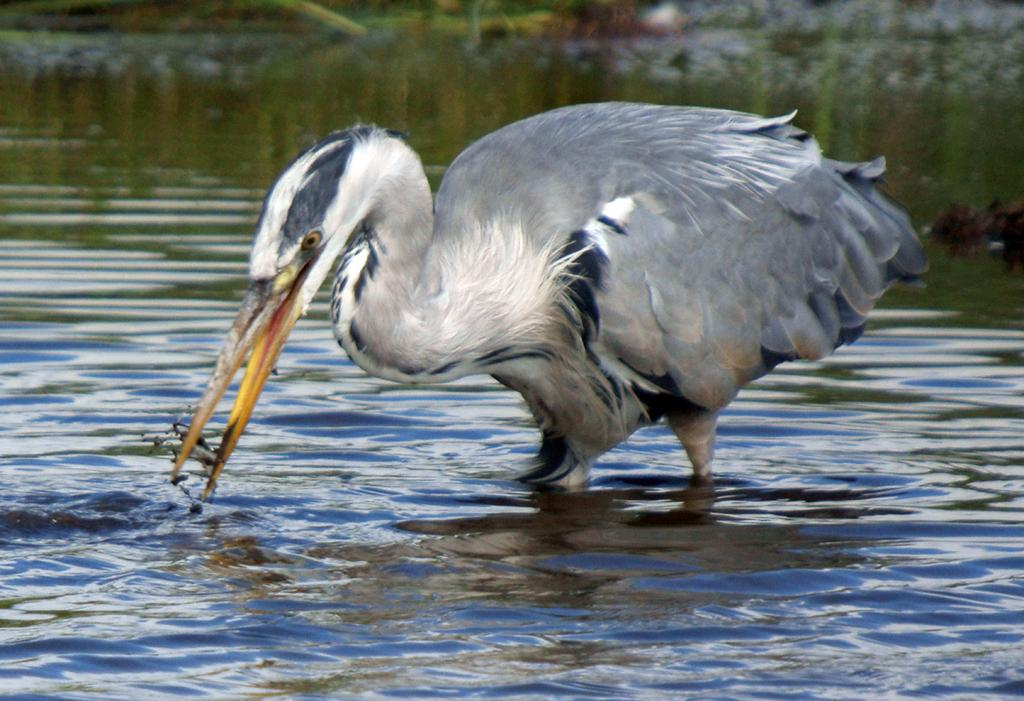What animal can be seen in the image? There is a bird in the image. What is the bird trying to do in the image? The bird is trying to catch fish in the image. Where is the bird located? The bird is in a water body in the image. Can you describe the background of the image? The background of the image is blurred. How many girls are playing with the pickle in the image? There are no girls or pickles present in the image; it features a bird trying to catch fish in a water body. 